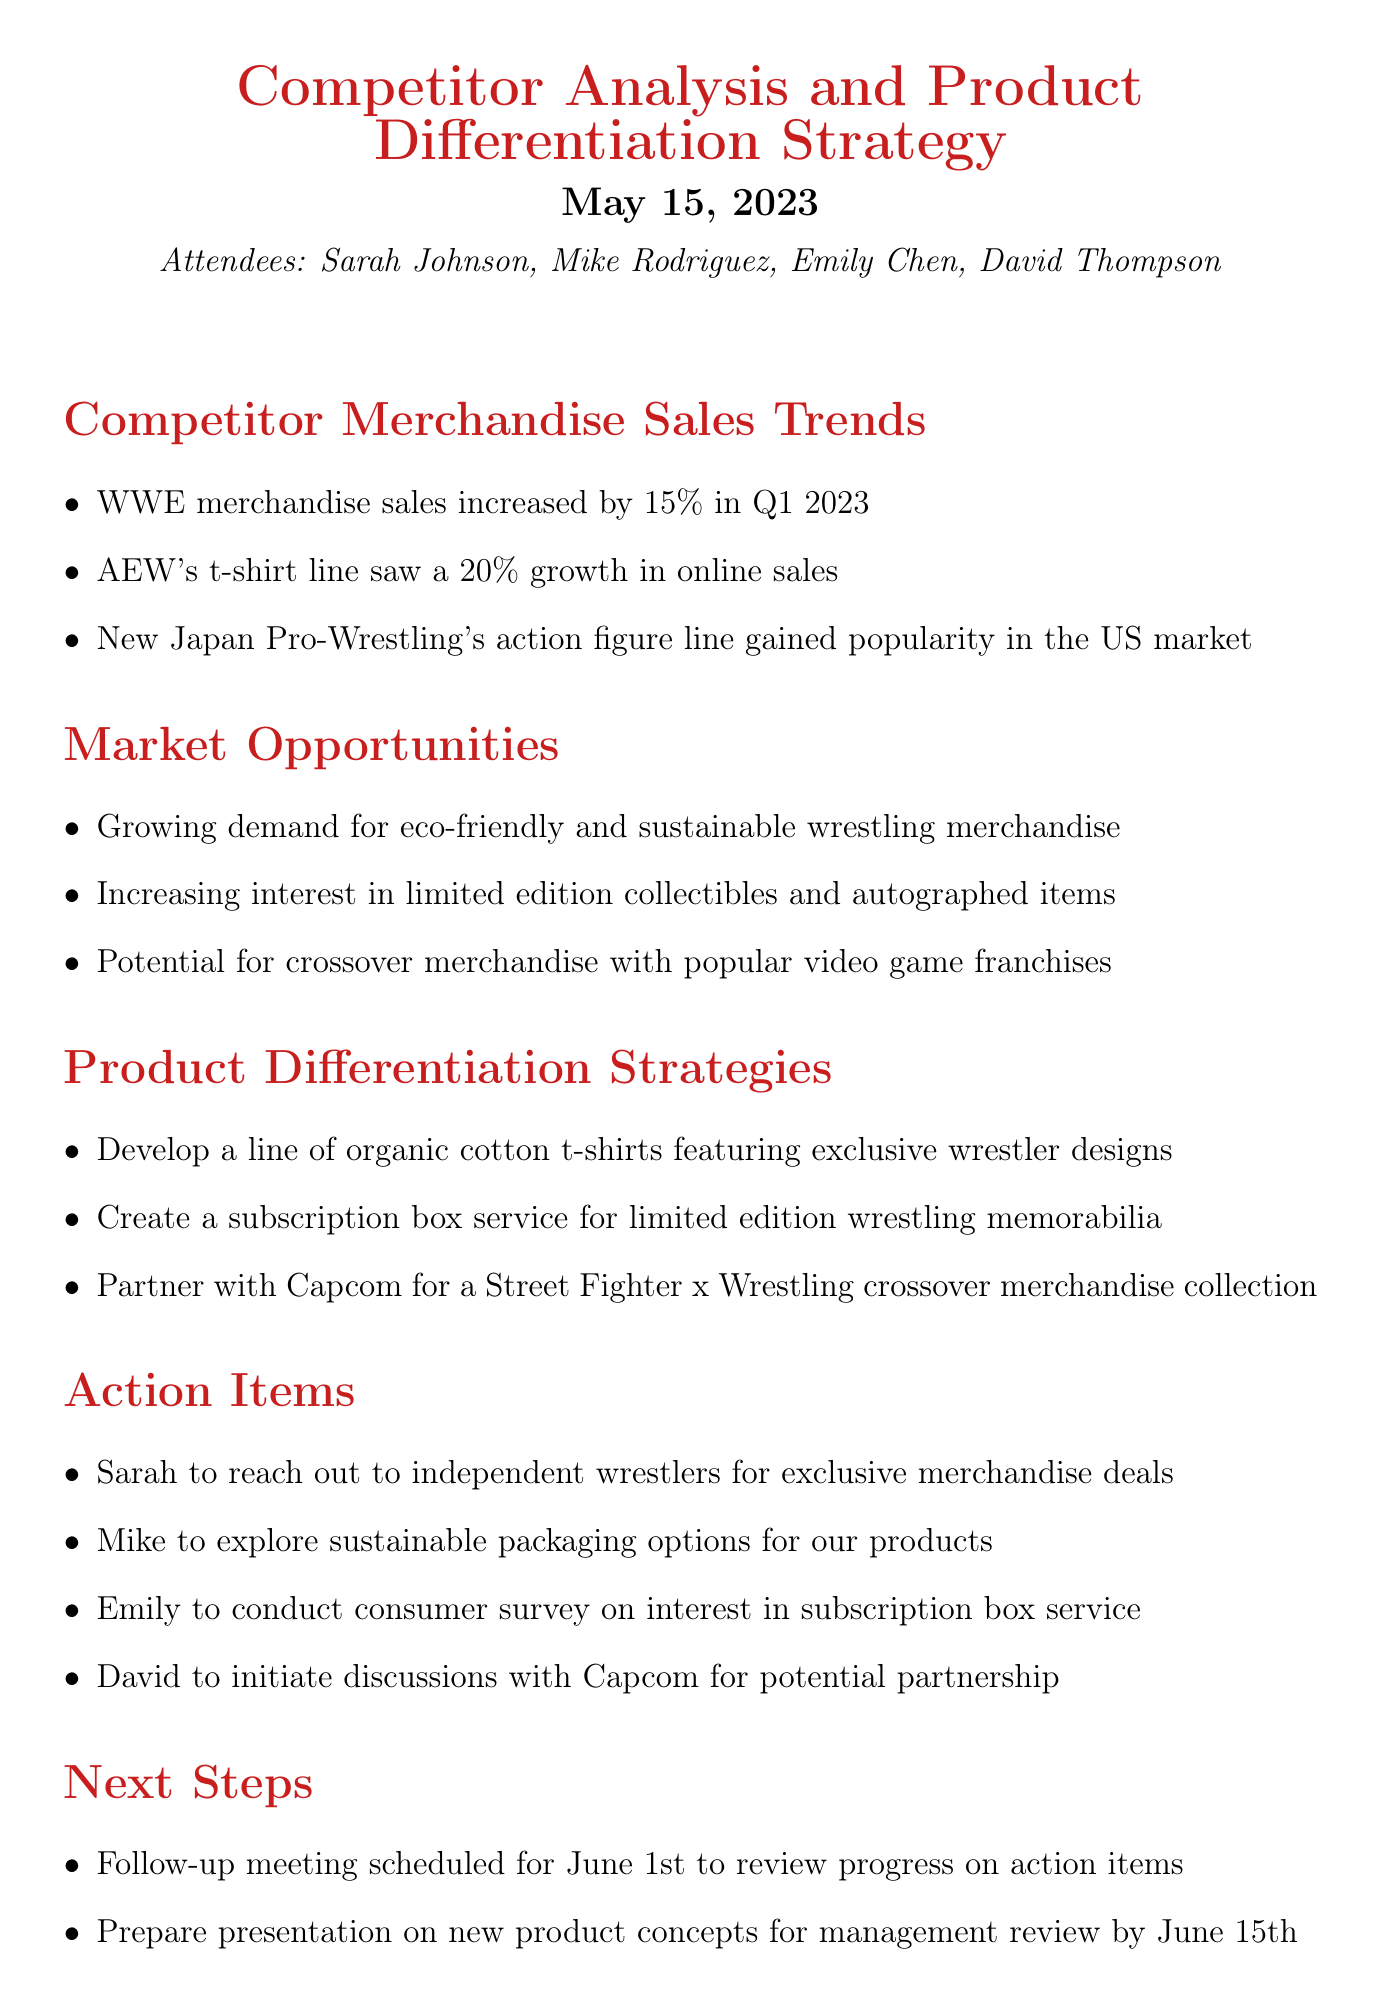What was the percentage increase in WWE merchandise sales in Q1 2023? The document states that WWE merchandise sales increased by 15% in Q1 2023.
Answer: 15% Which merchandise line of AEW saw a 20% growth? The document mentions that AEW's t-shirt line saw a 20% growth in online sales.
Answer: t-shirt line What is one market opportunity mentioned? The document lists growing demand for eco-friendly and sustainable wrestling merchandise as a market opportunity.
Answer: eco-friendly and sustainable wrestling merchandise What is a strategy for product differentiation mentioned? The document outlines a strategy to develop a line of organic cotton t-shirts featuring exclusive wrestler designs.
Answer: organic cotton t-shirts Who is responsible for reaching out to independent wrestlers for exclusive merchandise deals? According to the document, Sarah is tasked with reaching out to independent wrestlers for exclusive merchandise deals.
Answer: Sarah When is the follow-up meeting scheduled? The document states that the follow-up meeting is scheduled for June 1st.
Answer: June 1st What action item involves exploring sustainable packaging? The document indicates that Mike is to explore sustainable packaging options for the products.
Answer: Mike What crossover merchandise collaboration is suggested? The document proposes a partnership with Capcom for a Street Fighter x Wrestling crossover merchandise collection.
Answer: Street Fighter x Wrestling What is the date for the presentation on new product concepts? The document specifies that the presentation on new product concepts is due by June 15th.
Answer: June 15th 